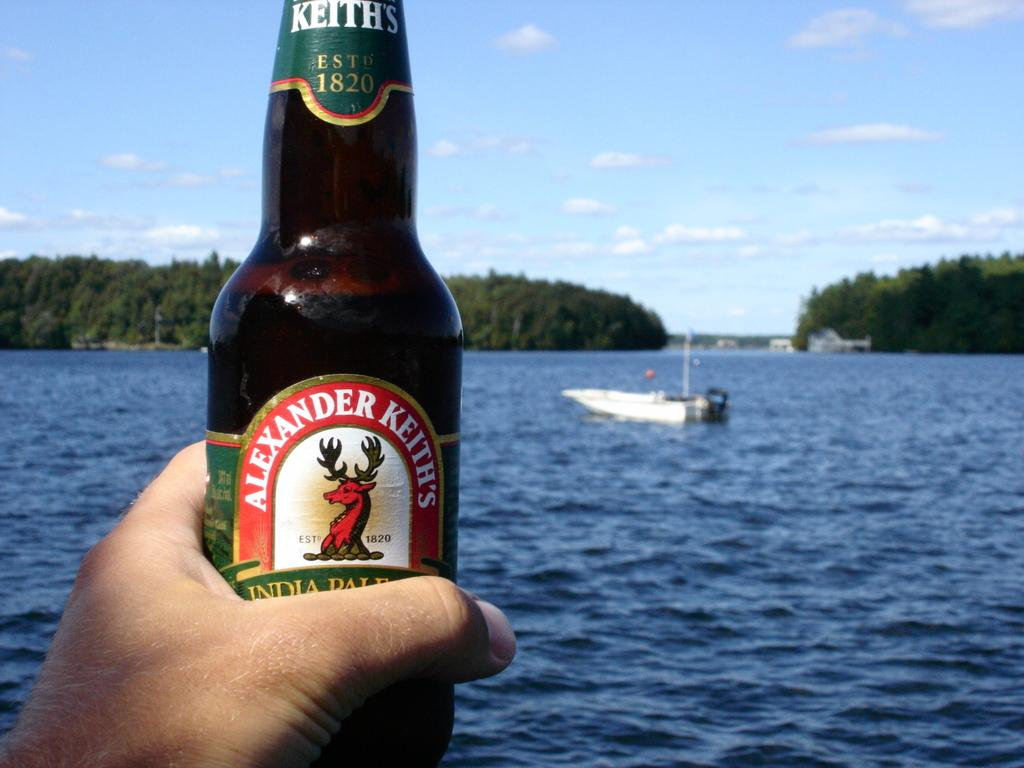Provide a one-sentence caption for the provided image. Someone is holding an Alexander Keith's bottle with a lake in the background. 